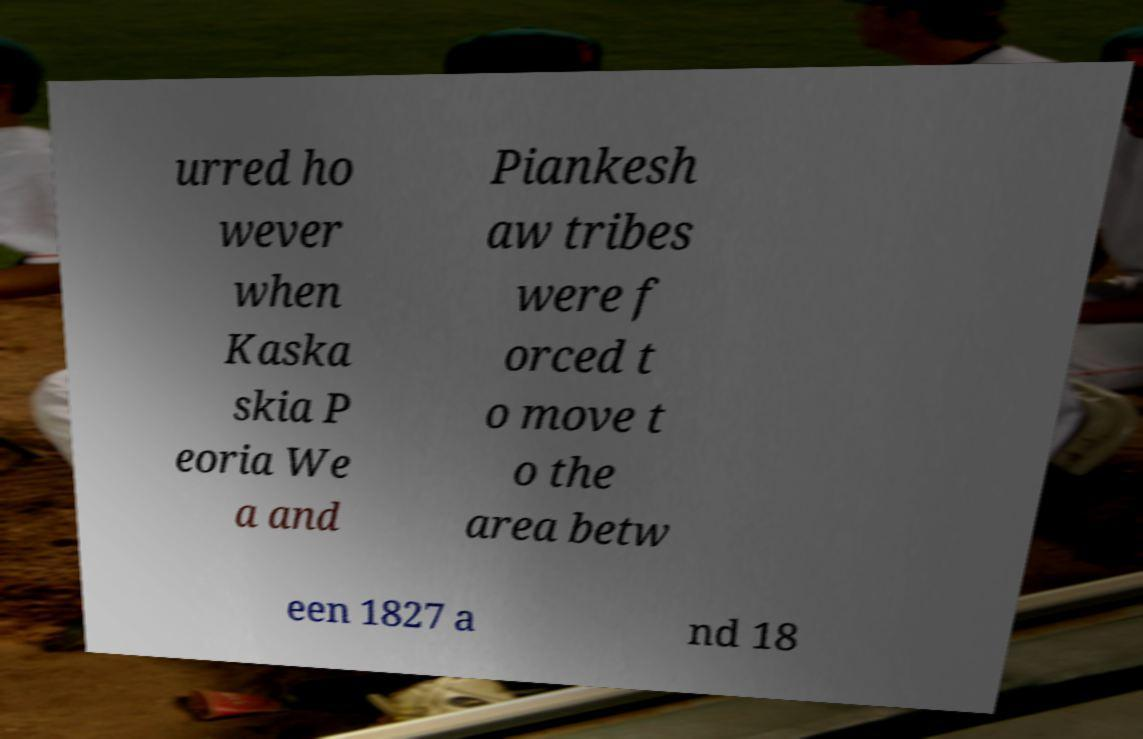For documentation purposes, I need the text within this image transcribed. Could you provide that? urred ho wever when Kaska skia P eoria We a and Piankesh aw tribes were f orced t o move t o the area betw een 1827 a nd 18 